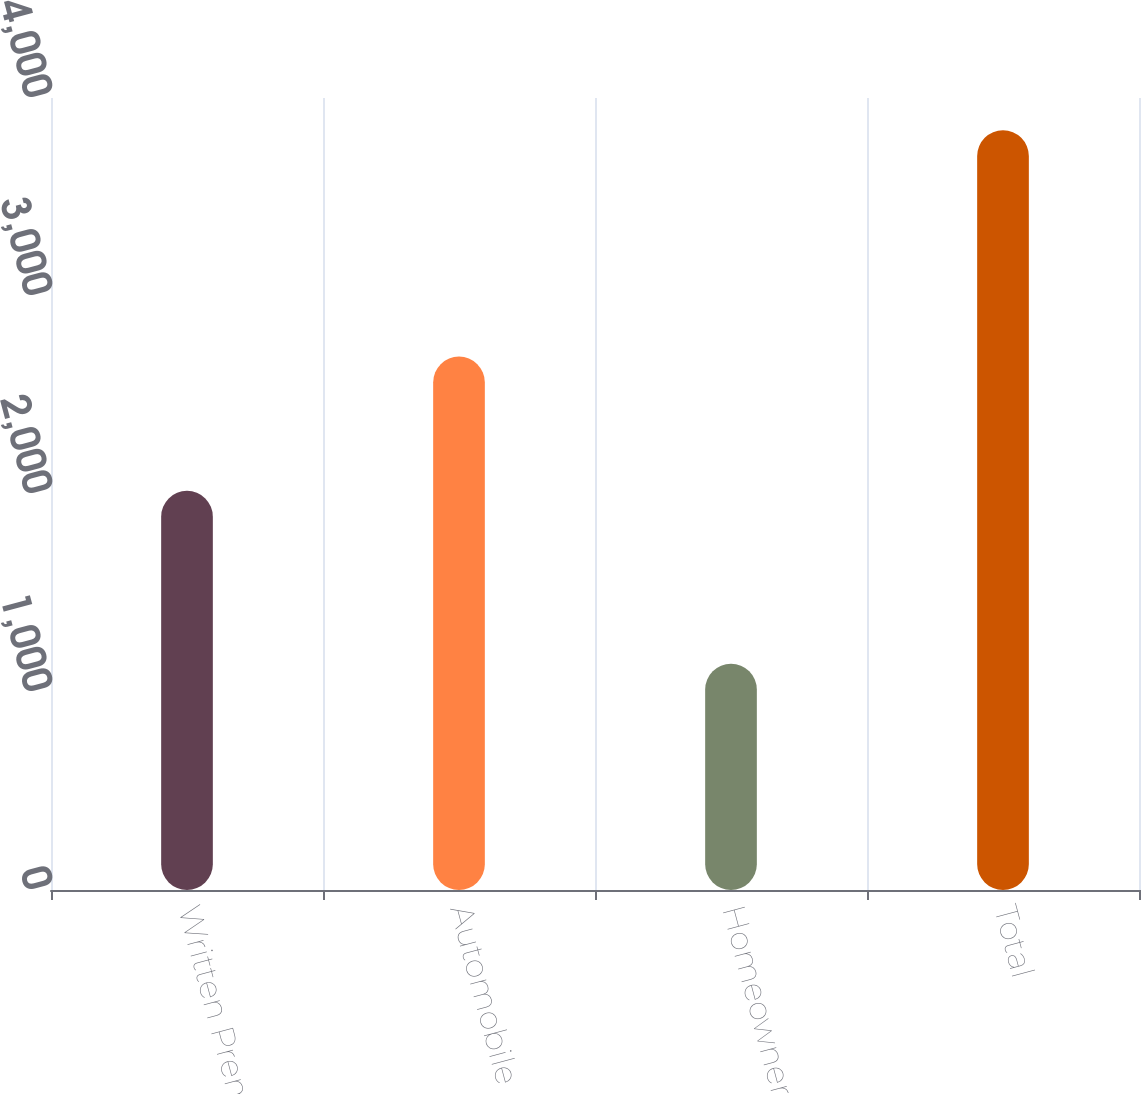Convert chart to OTSL. <chart><loc_0><loc_0><loc_500><loc_500><bar_chart><fcel>Written Premiums<fcel>Automobile<fcel>Homeowners<fcel>Total<nl><fcel>2016<fcel>2694<fcel>1143<fcel>3837<nl></chart> 